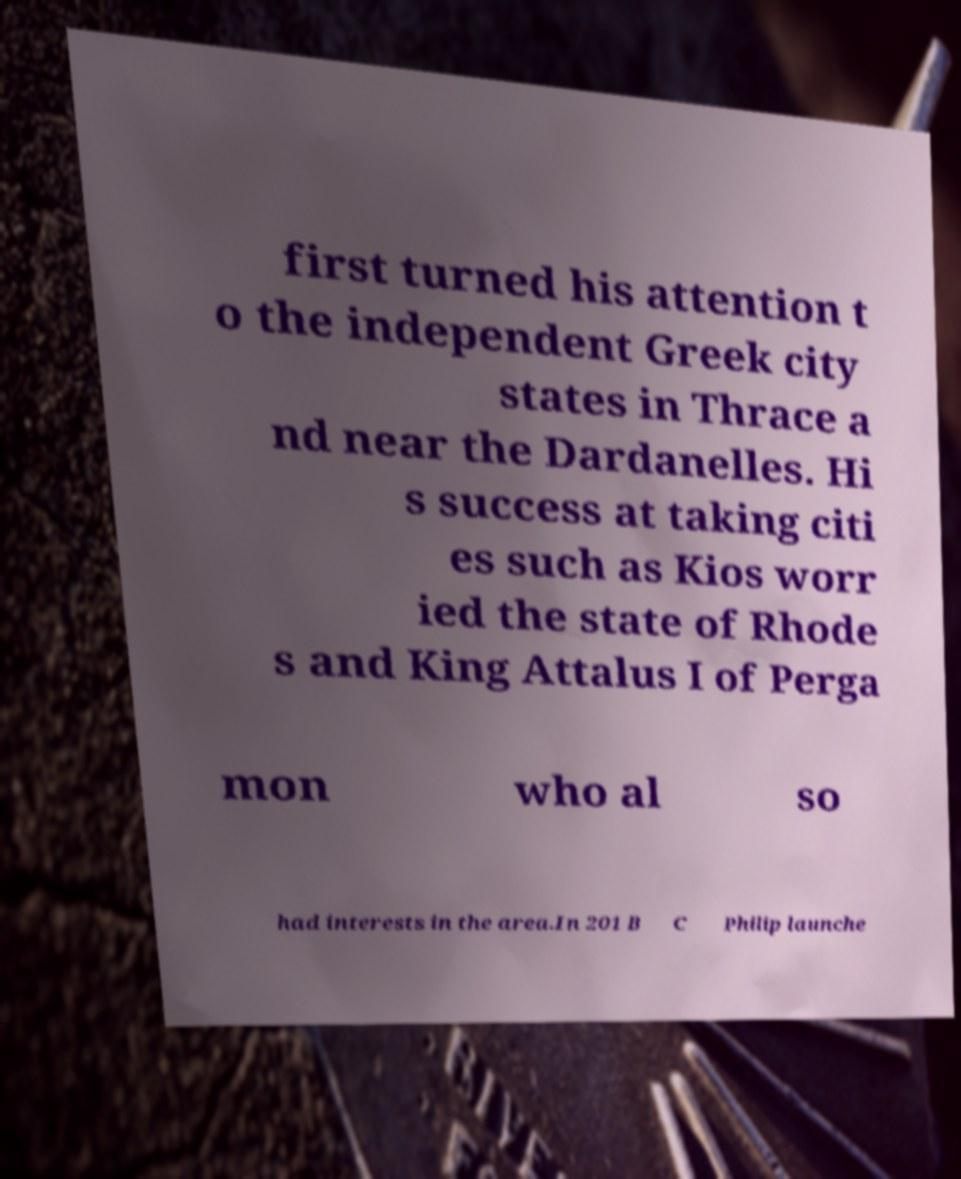Could you extract and type out the text from this image? first turned his attention t o the independent Greek city states in Thrace a nd near the Dardanelles. Hi s success at taking citi es such as Kios worr ied the state of Rhode s and King Attalus I of Perga mon who al so had interests in the area.In 201 B C Philip launche 